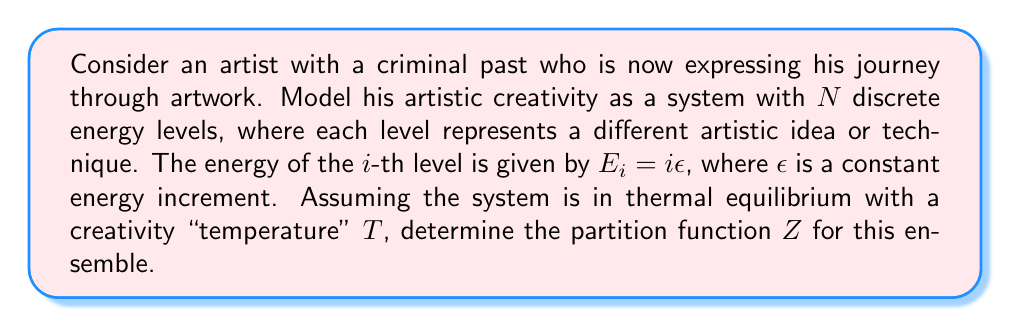Give your solution to this math problem. To solve this problem, we'll follow these steps:

1) The partition function $Z$ for a system with discrete energy levels is given by:

   $$Z = \sum_{i} e^{-\beta E_i}$$

   where $\beta = \frac{1}{k_B T}$, $k_B$ is Boltzmann's constant, and $T$ is the temperature.

2) In our case, $E_i = i\epsilon$, so we can rewrite the partition function as:

   $$Z = \sum_{i=0}^{N-1} e^{-\beta i\epsilon}$$

3) This is a geometric series with $N$ terms, where the first term is 1 and the common ratio is $e^{-\beta\epsilon}$. We can use the formula for the sum of a geometric series:

   $$S_N = \frac{1-r^N}{1-r}$$

   where $r$ is the common ratio.

4) In our case, $r = e^{-\beta\epsilon}$, so:

   $$Z = \frac{1-e^{-N\beta\epsilon}}{1-e^{-\beta\epsilon}}$$

5) This expression represents the partition function for the artistic creativity model, where $N$ is the number of discrete energy levels, $\beta = \frac{1}{k_B T}$, and $\epsilon$ is the energy increment between levels.
Answer: $Z = \frac{1-e^{-N\beta\epsilon}}{1-e^{-\beta\epsilon}}$ 